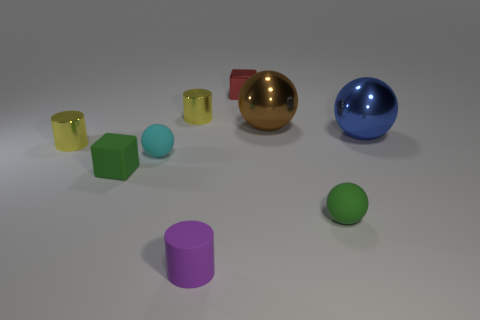Is the red object the same shape as the blue object?
Make the answer very short. No. There is a thing that is the same color as the small rubber block; what size is it?
Offer a very short reply. Small. How many balls are left of the tiny metal thing that is in front of the big brown thing?
Offer a terse response. 0. What number of large spheres are both left of the blue metallic ball and to the right of the green sphere?
Give a very brief answer. 0. What number of objects are either big purple cylinders or yellow shiny cylinders in front of the brown ball?
Give a very brief answer. 1. What is the size of the red cube that is the same material as the blue object?
Provide a succinct answer. Small. What is the shape of the yellow metallic object right of the metal object in front of the blue ball?
Give a very brief answer. Cylinder. What number of brown things are either large metal spheres or cubes?
Your answer should be very brief. 1. There is a metallic cylinder to the right of the tiny yellow thing in front of the large blue ball; is there a tiny shiny object right of it?
Provide a succinct answer. Yes. What shape is the thing that is the same color as the rubber cube?
Offer a terse response. Sphere. 